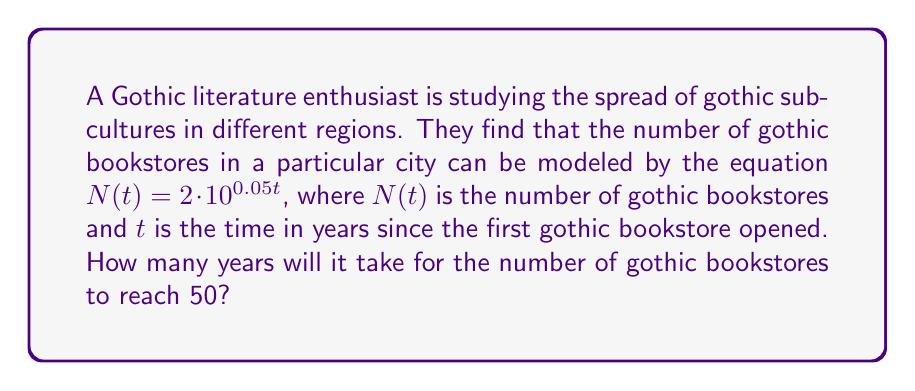Give your solution to this math problem. Let's solve this step-by-step:

1) We start with the equation: $N(t) = 2 \cdot 10^{0.05t}$

2) We want to find $t$ when $N(t) = 50$, so let's substitute this:

   $50 = 2 \cdot 10^{0.05t}$

3) Divide both sides by 2:

   $25 = 10^{0.05t}$

4) Now, we can take the logarithm (base 10) of both sides:

   $\log_{10}(25) = \log_{10}(10^{0.05t})$

5) Using the logarithm property $\log_a(a^x) = x$, we get:

   $\log_{10}(25) = 0.05t$

6) Now, we can solve for $t$:

   $t = \frac{\log_{10}(25)}{0.05}$

7) Calculate:
   $\log_{10}(25) \approx 1.3979$
   
   $t = \frac{1.3979}{0.05} \approx 27.958$

8) Since we're dealing with years, we round up to the nearest whole number.
Answer: 28 years 